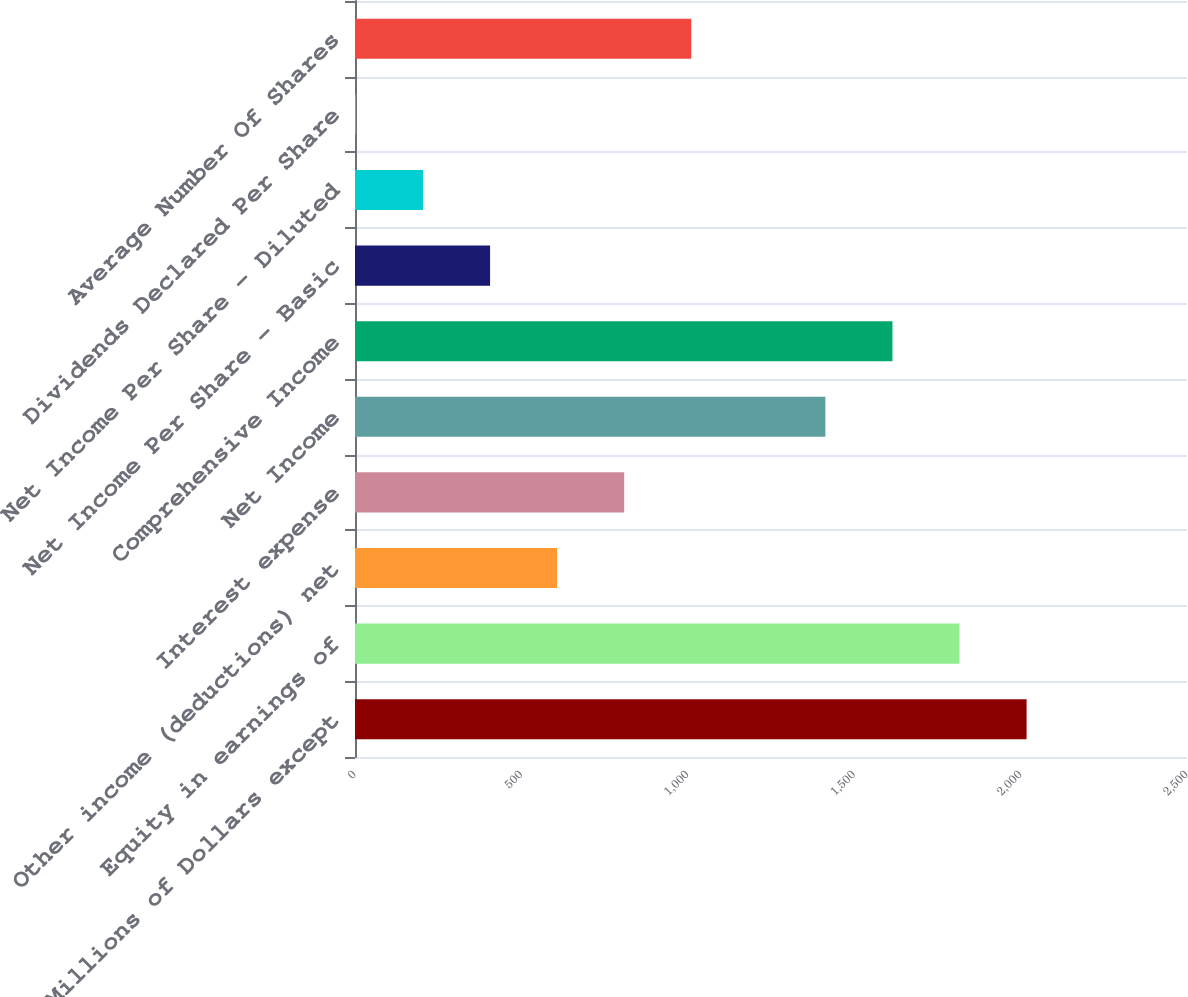<chart> <loc_0><loc_0><loc_500><loc_500><bar_chart><fcel>(Millions of Dollars except<fcel>Equity in earnings of<fcel>Other income (deductions) net<fcel>Interest expense<fcel>Net Income<fcel>Comprehensive Income<fcel>Net Income Per Share - Basic<fcel>Net Income Per Share - Diluted<fcel>Dividends Declared Per Share<fcel>Average Number Of Shares<nl><fcel>2018<fcel>1816.45<fcel>607.39<fcel>808.9<fcel>1413.43<fcel>1614.94<fcel>405.88<fcel>204.37<fcel>2.86<fcel>1010.41<nl></chart> 